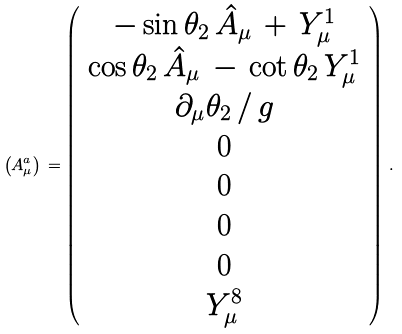Convert formula to latex. <formula><loc_0><loc_0><loc_500><loc_500>\left ( A ^ { a } _ { \mu } \right ) \, = \left ( \begin{array} { c } - \sin \theta _ { 2 } \, \hat { A } _ { \mu } \, + \, Y ^ { 1 } _ { \mu } \\ \cos \theta _ { 2 } \, \hat { A } _ { \mu } \, - \, \cot \theta _ { 2 } \, Y ^ { 1 } _ { \mu } \\ \partial _ { \mu } \theta _ { 2 } \, / \, g \\ 0 \\ 0 \\ 0 \\ 0 \\ Y ^ { 8 } _ { \mu } \end{array} \right ) \, .</formula> 